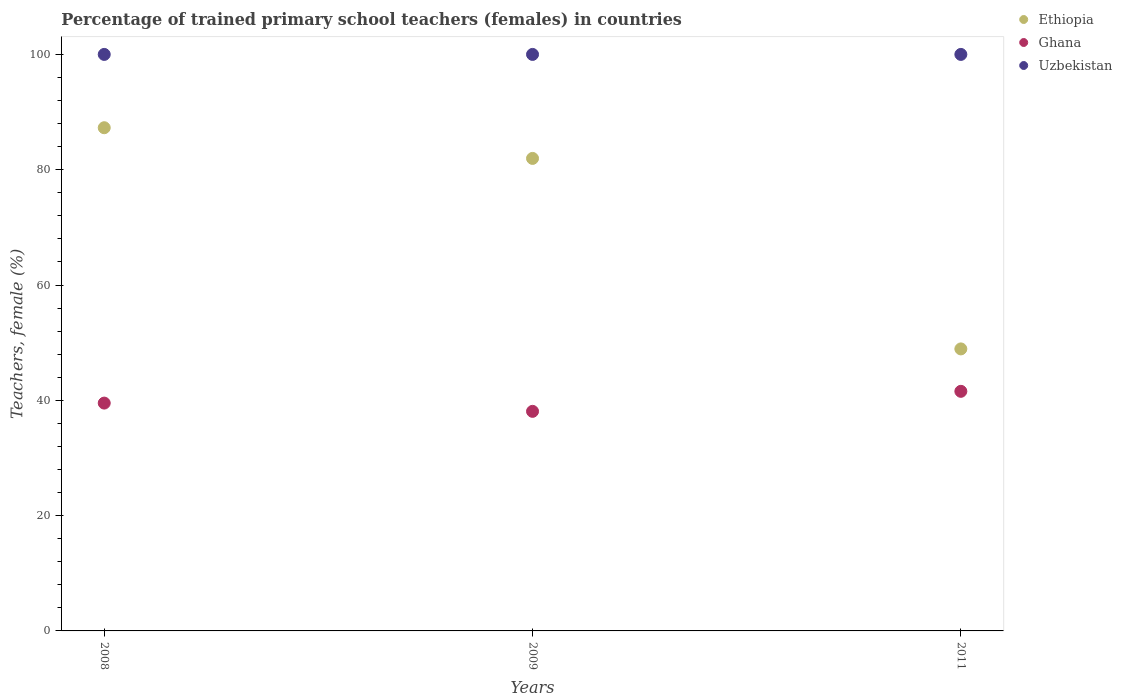How many different coloured dotlines are there?
Your answer should be very brief. 3. Is the number of dotlines equal to the number of legend labels?
Offer a very short reply. Yes. What is the percentage of trained primary school teachers (females) in Uzbekistan in 2011?
Offer a terse response. 100. Across all years, what is the maximum percentage of trained primary school teachers (females) in Ethiopia?
Your answer should be compact. 87.28. Across all years, what is the minimum percentage of trained primary school teachers (females) in Ghana?
Your response must be concise. 38.09. In which year was the percentage of trained primary school teachers (females) in Ethiopia minimum?
Make the answer very short. 2011. What is the total percentage of trained primary school teachers (females) in Uzbekistan in the graph?
Offer a terse response. 300. What is the difference between the percentage of trained primary school teachers (females) in Ethiopia in 2009 and that in 2011?
Offer a very short reply. 33.04. What is the difference between the percentage of trained primary school teachers (females) in Ethiopia in 2009 and the percentage of trained primary school teachers (females) in Ghana in 2008?
Your answer should be very brief. 42.44. What is the average percentage of trained primary school teachers (females) in Uzbekistan per year?
Offer a very short reply. 100. In the year 2008, what is the difference between the percentage of trained primary school teachers (females) in Ethiopia and percentage of trained primary school teachers (females) in Ghana?
Offer a terse response. 47.77. What is the ratio of the percentage of trained primary school teachers (females) in Uzbekistan in 2008 to that in 2011?
Your answer should be compact. 1. Is the percentage of trained primary school teachers (females) in Ethiopia in 2009 less than that in 2011?
Your answer should be compact. No. What is the difference between the highest and the lowest percentage of trained primary school teachers (females) in Uzbekistan?
Your response must be concise. 0. In how many years, is the percentage of trained primary school teachers (females) in Uzbekistan greater than the average percentage of trained primary school teachers (females) in Uzbekistan taken over all years?
Offer a terse response. 0. Is the sum of the percentage of trained primary school teachers (females) in Ethiopia in 2009 and 2011 greater than the maximum percentage of trained primary school teachers (females) in Uzbekistan across all years?
Offer a very short reply. Yes. Is it the case that in every year, the sum of the percentage of trained primary school teachers (females) in Uzbekistan and percentage of trained primary school teachers (females) in Ghana  is greater than the percentage of trained primary school teachers (females) in Ethiopia?
Provide a succinct answer. Yes. Is the percentage of trained primary school teachers (females) in Uzbekistan strictly greater than the percentage of trained primary school teachers (females) in Ghana over the years?
Keep it short and to the point. Yes. Is the percentage of trained primary school teachers (females) in Uzbekistan strictly less than the percentage of trained primary school teachers (females) in Ghana over the years?
Your answer should be compact. No. How many years are there in the graph?
Provide a short and direct response. 3. What is the difference between two consecutive major ticks on the Y-axis?
Provide a succinct answer. 20. Are the values on the major ticks of Y-axis written in scientific E-notation?
Make the answer very short. No. Does the graph contain any zero values?
Keep it short and to the point. No. Does the graph contain grids?
Keep it short and to the point. No. Where does the legend appear in the graph?
Your answer should be compact. Top right. How many legend labels are there?
Offer a very short reply. 3. What is the title of the graph?
Ensure brevity in your answer.  Percentage of trained primary school teachers (females) in countries. What is the label or title of the X-axis?
Offer a very short reply. Years. What is the label or title of the Y-axis?
Your answer should be compact. Teachers, female (%). What is the Teachers, female (%) in Ethiopia in 2008?
Your answer should be compact. 87.28. What is the Teachers, female (%) in Ghana in 2008?
Give a very brief answer. 39.52. What is the Teachers, female (%) of Uzbekistan in 2008?
Ensure brevity in your answer.  100. What is the Teachers, female (%) in Ethiopia in 2009?
Give a very brief answer. 81.96. What is the Teachers, female (%) of Ghana in 2009?
Keep it short and to the point. 38.09. What is the Teachers, female (%) in Uzbekistan in 2009?
Keep it short and to the point. 100. What is the Teachers, female (%) in Ethiopia in 2011?
Provide a succinct answer. 48.92. What is the Teachers, female (%) in Ghana in 2011?
Your response must be concise. 41.56. What is the Teachers, female (%) in Uzbekistan in 2011?
Provide a succinct answer. 100. Across all years, what is the maximum Teachers, female (%) in Ethiopia?
Your response must be concise. 87.28. Across all years, what is the maximum Teachers, female (%) in Ghana?
Provide a short and direct response. 41.56. Across all years, what is the minimum Teachers, female (%) of Ethiopia?
Your answer should be very brief. 48.92. Across all years, what is the minimum Teachers, female (%) of Ghana?
Your answer should be very brief. 38.09. What is the total Teachers, female (%) in Ethiopia in the graph?
Your response must be concise. 218.16. What is the total Teachers, female (%) in Ghana in the graph?
Keep it short and to the point. 119.17. What is the total Teachers, female (%) of Uzbekistan in the graph?
Your answer should be very brief. 300. What is the difference between the Teachers, female (%) in Ethiopia in 2008 and that in 2009?
Offer a very short reply. 5.32. What is the difference between the Teachers, female (%) of Ghana in 2008 and that in 2009?
Your response must be concise. 1.43. What is the difference between the Teachers, female (%) of Ethiopia in 2008 and that in 2011?
Ensure brevity in your answer.  38.37. What is the difference between the Teachers, female (%) in Ghana in 2008 and that in 2011?
Your answer should be compact. -2.04. What is the difference between the Teachers, female (%) in Uzbekistan in 2008 and that in 2011?
Your answer should be compact. 0. What is the difference between the Teachers, female (%) in Ethiopia in 2009 and that in 2011?
Your answer should be very brief. 33.04. What is the difference between the Teachers, female (%) of Ghana in 2009 and that in 2011?
Your answer should be very brief. -3.47. What is the difference between the Teachers, female (%) in Ethiopia in 2008 and the Teachers, female (%) in Ghana in 2009?
Give a very brief answer. 49.2. What is the difference between the Teachers, female (%) of Ethiopia in 2008 and the Teachers, female (%) of Uzbekistan in 2009?
Keep it short and to the point. -12.72. What is the difference between the Teachers, female (%) in Ghana in 2008 and the Teachers, female (%) in Uzbekistan in 2009?
Provide a short and direct response. -60.48. What is the difference between the Teachers, female (%) of Ethiopia in 2008 and the Teachers, female (%) of Ghana in 2011?
Ensure brevity in your answer.  45.72. What is the difference between the Teachers, female (%) in Ethiopia in 2008 and the Teachers, female (%) in Uzbekistan in 2011?
Ensure brevity in your answer.  -12.72. What is the difference between the Teachers, female (%) in Ghana in 2008 and the Teachers, female (%) in Uzbekistan in 2011?
Keep it short and to the point. -60.48. What is the difference between the Teachers, female (%) of Ethiopia in 2009 and the Teachers, female (%) of Ghana in 2011?
Provide a succinct answer. 40.4. What is the difference between the Teachers, female (%) in Ethiopia in 2009 and the Teachers, female (%) in Uzbekistan in 2011?
Make the answer very short. -18.04. What is the difference between the Teachers, female (%) in Ghana in 2009 and the Teachers, female (%) in Uzbekistan in 2011?
Provide a succinct answer. -61.91. What is the average Teachers, female (%) of Ethiopia per year?
Keep it short and to the point. 72.72. What is the average Teachers, female (%) of Ghana per year?
Provide a succinct answer. 39.72. In the year 2008, what is the difference between the Teachers, female (%) of Ethiopia and Teachers, female (%) of Ghana?
Provide a short and direct response. 47.77. In the year 2008, what is the difference between the Teachers, female (%) in Ethiopia and Teachers, female (%) in Uzbekistan?
Give a very brief answer. -12.72. In the year 2008, what is the difference between the Teachers, female (%) in Ghana and Teachers, female (%) in Uzbekistan?
Offer a terse response. -60.48. In the year 2009, what is the difference between the Teachers, female (%) in Ethiopia and Teachers, female (%) in Ghana?
Give a very brief answer. 43.87. In the year 2009, what is the difference between the Teachers, female (%) of Ethiopia and Teachers, female (%) of Uzbekistan?
Ensure brevity in your answer.  -18.04. In the year 2009, what is the difference between the Teachers, female (%) of Ghana and Teachers, female (%) of Uzbekistan?
Provide a short and direct response. -61.91. In the year 2011, what is the difference between the Teachers, female (%) of Ethiopia and Teachers, female (%) of Ghana?
Provide a succinct answer. 7.36. In the year 2011, what is the difference between the Teachers, female (%) in Ethiopia and Teachers, female (%) in Uzbekistan?
Provide a short and direct response. -51.08. In the year 2011, what is the difference between the Teachers, female (%) in Ghana and Teachers, female (%) in Uzbekistan?
Make the answer very short. -58.44. What is the ratio of the Teachers, female (%) of Ethiopia in 2008 to that in 2009?
Offer a terse response. 1.06. What is the ratio of the Teachers, female (%) of Ghana in 2008 to that in 2009?
Your answer should be compact. 1.04. What is the ratio of the Teachers, female (%) of Uzbekistan in 2008 to that in 2009?
Your answer should be compact. 1. What is the ratio of the Teachers, female (%) of Ethiopia in 2008 to that in 2011?
Your answer should be compact. 1.78. What is the ratio of the Teachers, female (%) of Ghana in 2008 to that in 2011?
Give a very brief answer. 0.95. What is the ratio of the Teachers, female (%) of Uzbekistan in 2008 to that in 2011?
Provide a short and direct response. 1. What is the ratio of the Teachers, female (%) in Ethiopia in 2009 to that in 2011?
Provide a short and direct response. 1.68. What is the ratio of the Teachers, female (%) of Ghana in 2009 to that in 2011?
Your response must be concise. 0.92. What is the ratio of the Teachers, female (%) in Uzbekistan in 2009 to that in 2011?
Keep it short and to the point. 1. What is the difference between the highest and the second highest Teachers, female (%) in Ethiopia?
Your answer should be compact. 5.32. What is the difference between the highest and the second highest Teachers, female (%) in Ghana?
Your answer should be very brief. 2.04. What is the difference between the highest and the second highest Teachers, female (%) of Uzbekistan?
Ensure brevity in your answer.  0. What is the difference between the highest and the lowest Teachers, female (%) in Ethiopia?
Your answer should be very brief. 38.37. What is the difference between the highest and the lowest Teachers, female (%) of Ghana?
Offer a terse response. 3.47. What is the difference between the highest and the lowest Teachers, female (%) of Uzbekistan?
Ensure brevity in your answer.  0. 